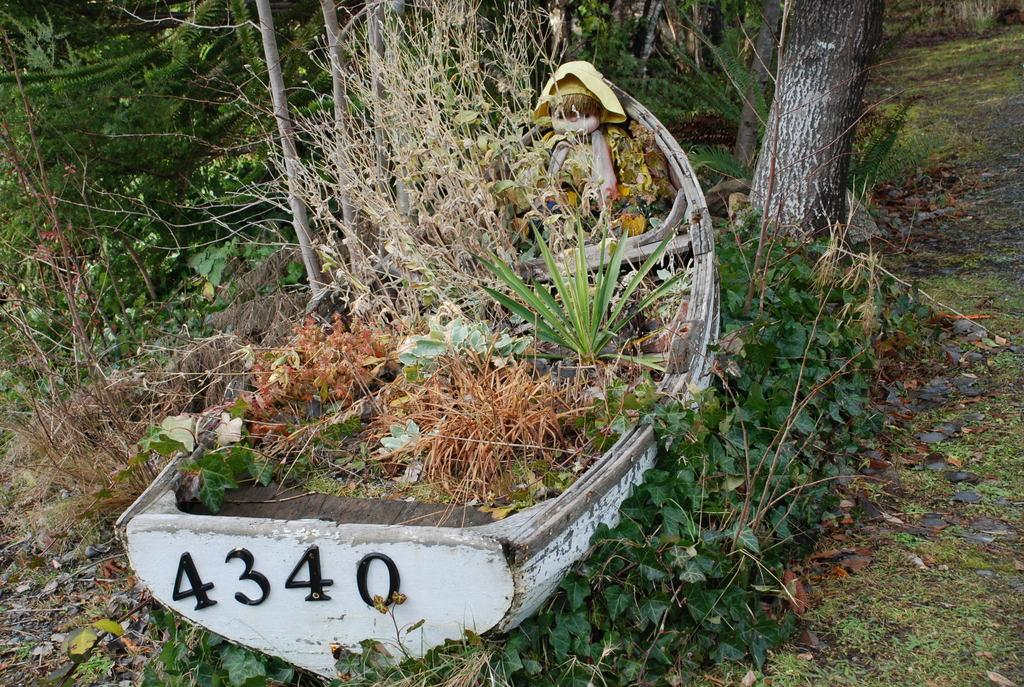What type of vehicle is in the image? There is a wooden boat in the image. What is inside the boat? There are plants and a doll in the boat. Are there any plants outside the boat? Yes, there are plants on both sides of the boat. What can be seen on the right side of the image? There is a tree on the right side of the image. What type of insect can be seen solving a riddle in the image? There is no insect present in the image, nor is there any riddle being solved. 